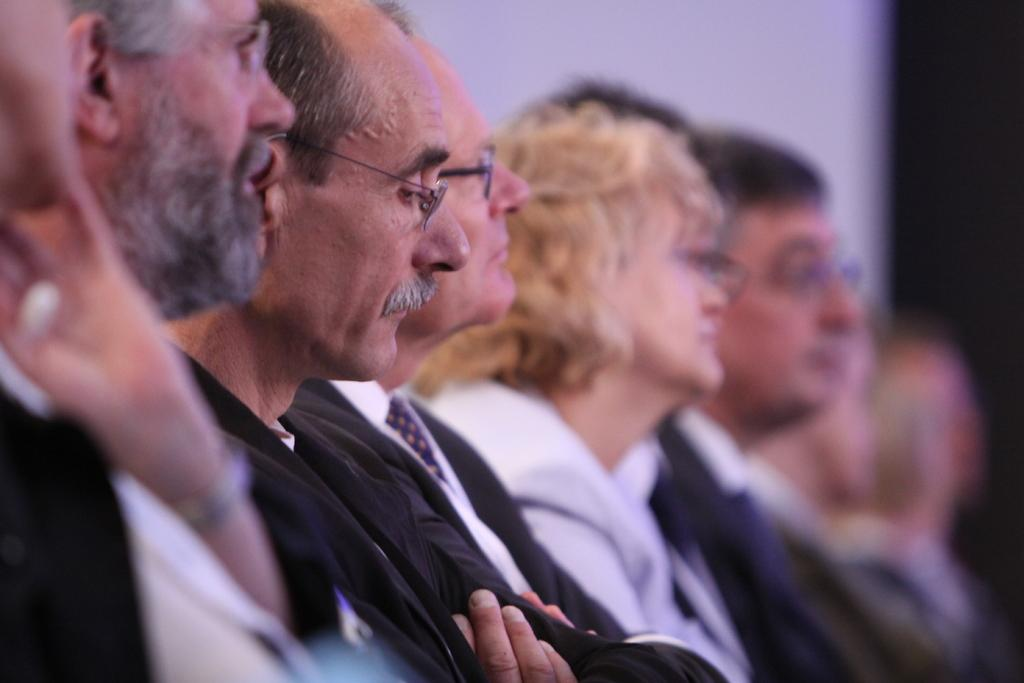How many people are in the image? There is a group of persons in the image, but the exact number cannot be determined without more information. What can be seen in the background of the image? The background of the image is blurred, so it is difficult to make out specific details. Where is the sink located in the image? There is no sink present in the image. What is the relationship between the persons in the image? The facts do not provide any information about the relationship between the persons in the image, so we cannot determine if they are siblings, friends, or strangers. 